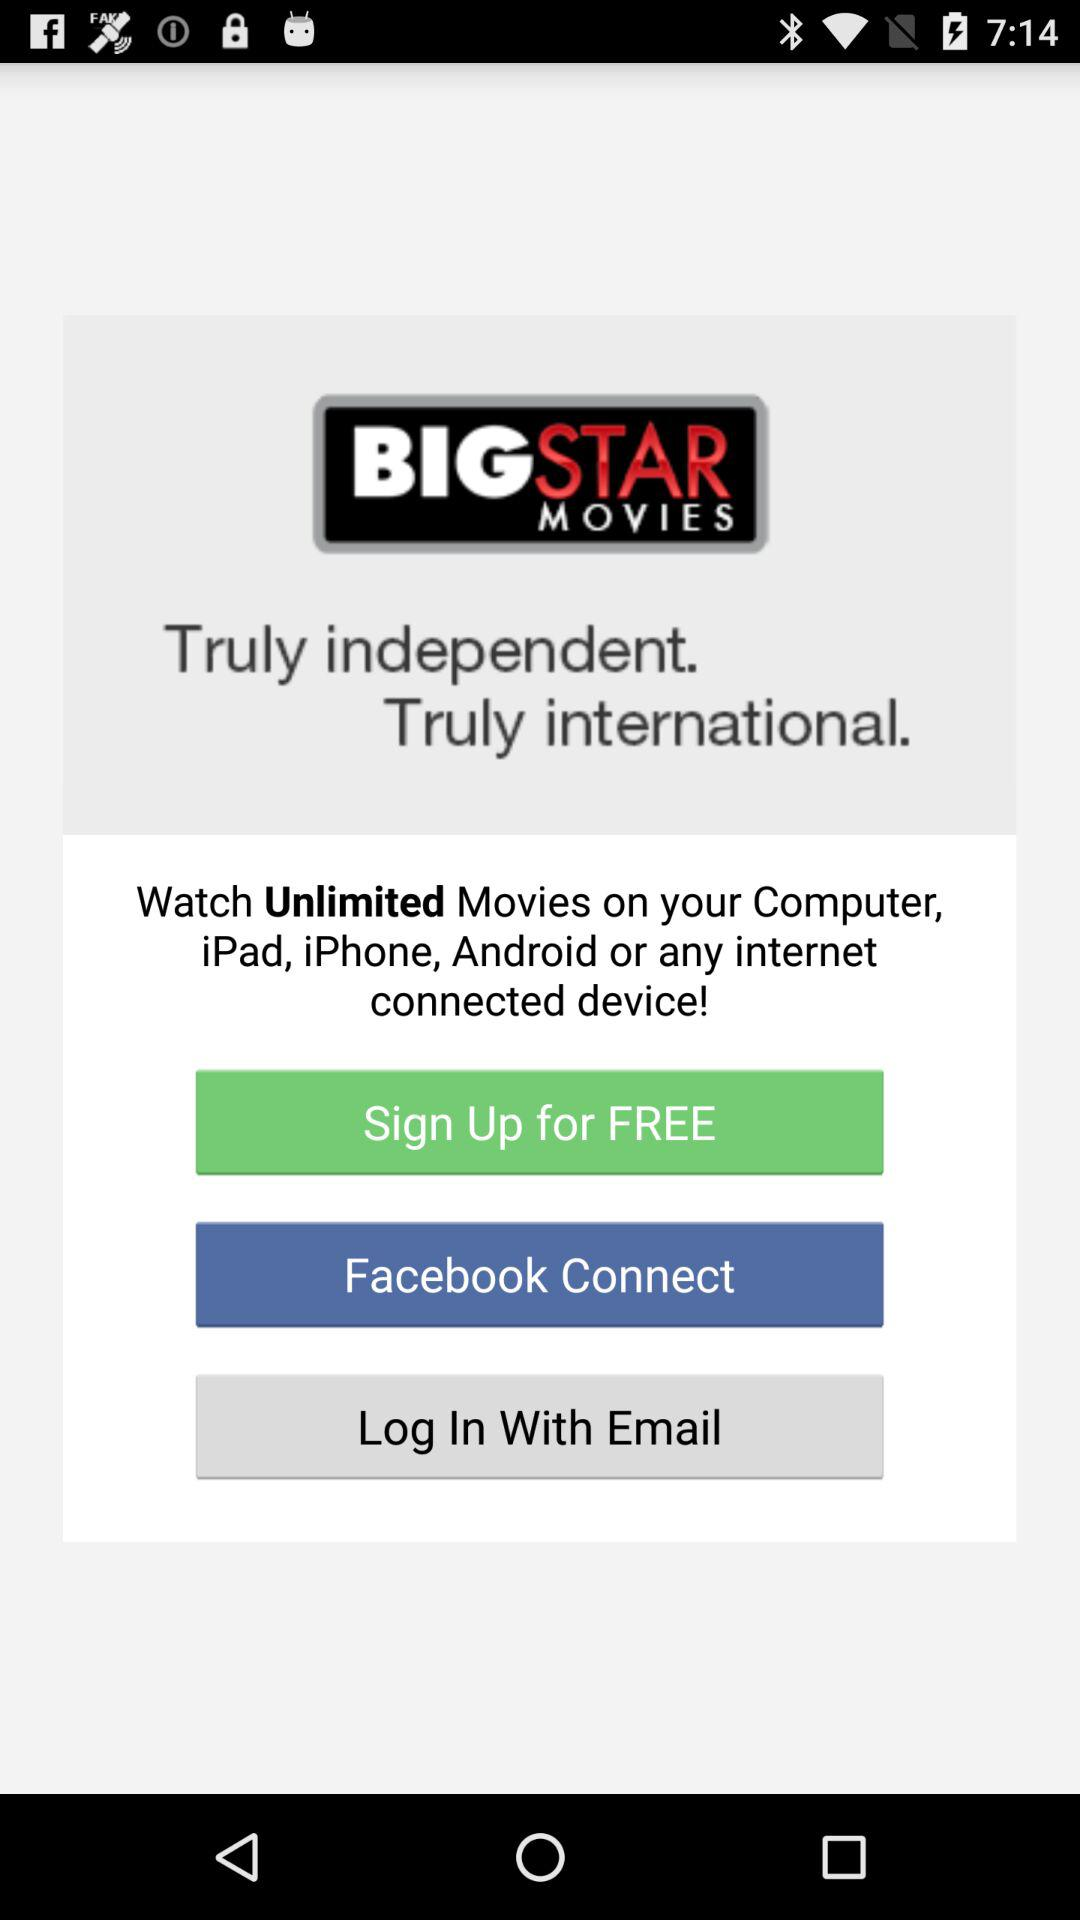How can we log in? You can log in with "Facebook" and "Email". 